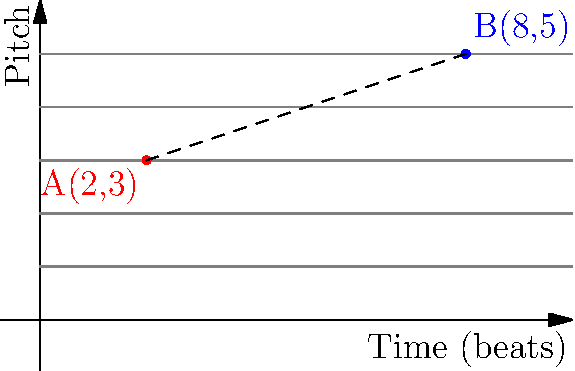In a musical staff-like coordinate system, where the x-axis represents time in beats and the y-axis represents pitch, two points A(2,3) and B(8,5) mark the start and end of a musical phrase. Calculate the distance between these two points, representing the "length" of the phrase in this coordinate space. Round your answer to two decimal places. To find the distance between two points in a coordinate system, we can use the distance formula, which is derived from the Pythagorean theorem:

$$d = \sqrt{(x_2 - x_1)^2 + (y_2 - y_1)^2}$$

Where $(x_1, y_1)$ are the coordinates of the first point and $(x_2, y_2)$ are the coordinates of the second point.

Given:
Point A: $(x_1, y_1) = (2, 3)$
Point B: $(x_2, y_2) = (8, 5)$

Let's plug these values into the formula:

$$d = \sqrt{(8 - 2)^2 + (5 - 3)^2}$$

Simplify:
$$d = \sqrt{6^2 + 2^2}$$

Calculate the squares:
$$d = \sqrt{36 + 4}$$

Add under the square root:
$$d = \sqrt{40}$$

Simplify:
$$d = 2\sqrt{10}$$

Calculate and round to two decimal places:
$$d \approx 6.32$$

This value represents the "length" of the musical phrase in our coordinate space, combining both the time duration (x-axis) and the pitch change (y-axis).
Answer: 6.32 